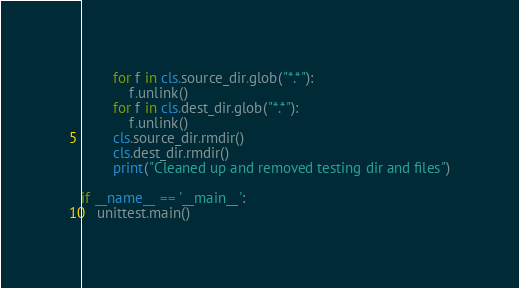<code> <loc_0><loc_0><loc_500><loc_500><_Python_>        for f in cls.source_dir.glob("*.*"):
            f.unlink()
        for f in cls.dest_dir.glob("*.*"):
            f.unlink()
        cls.source_dir.rmdir()
        cls.dest_dir.rmdir()
        print("Cleaned up and removed testing dir and files")

if __name__ == '__main__':
    unittest.main()
</code> 